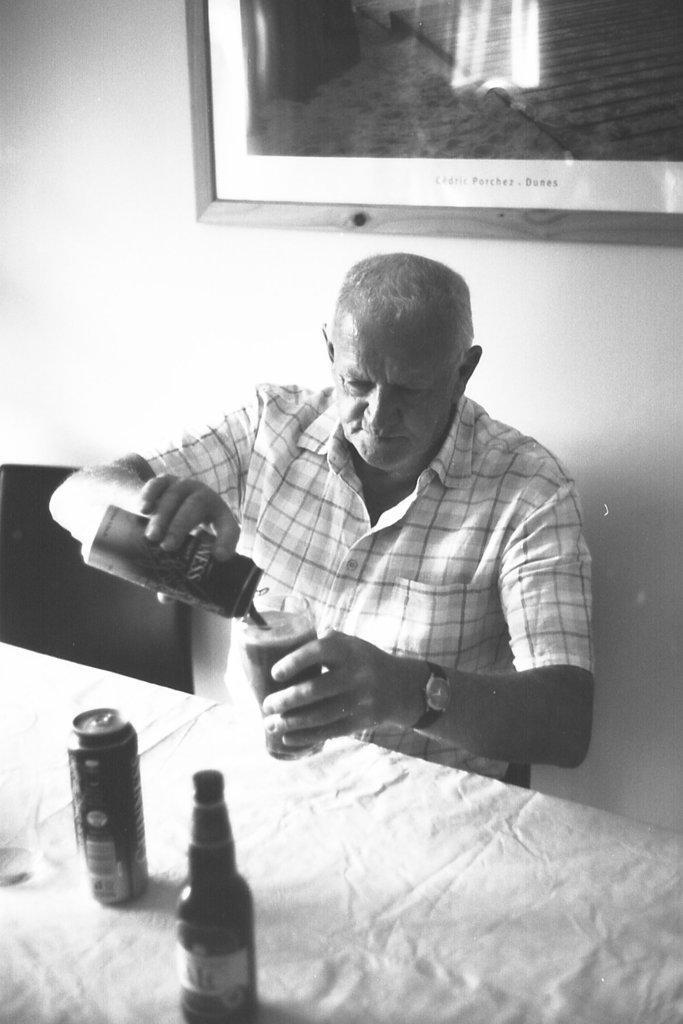Could you give a brief overview of what you see in this image? This is a black and white picture. On the background we can see a photo frame over a wall. Here we can see one old man sitting on chair infront of a table and on the table we can see tin and a bottle. We can see this man poring a drink into the glass. Here this is an empty chair. 